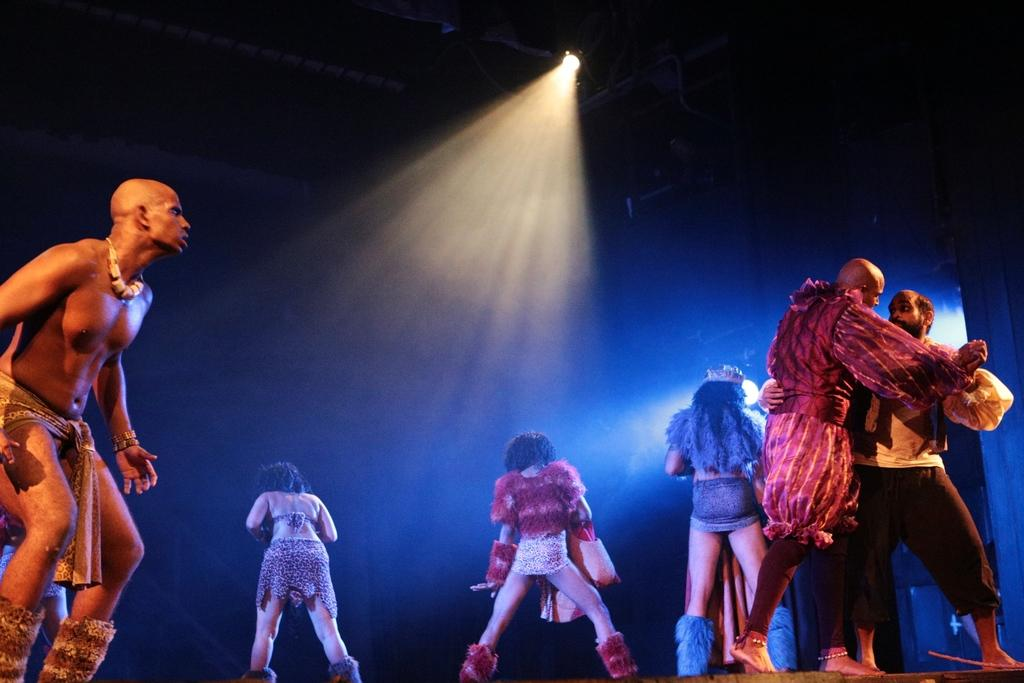What are the people in the image doing? The people in the image are performing dance. What is the color of the background in the image? The background of the image is dark. What can be seen in addition to the people dancing in the image? There are lights visible in the image. What type of wax is being used by the dancers in the image? There is no wax present in the image, and the dancers are not using any wax. Can you tell me how many beams are supporting the stage in the image? There is no stage or beams visible in the image; it only shows people dancing and lights. 